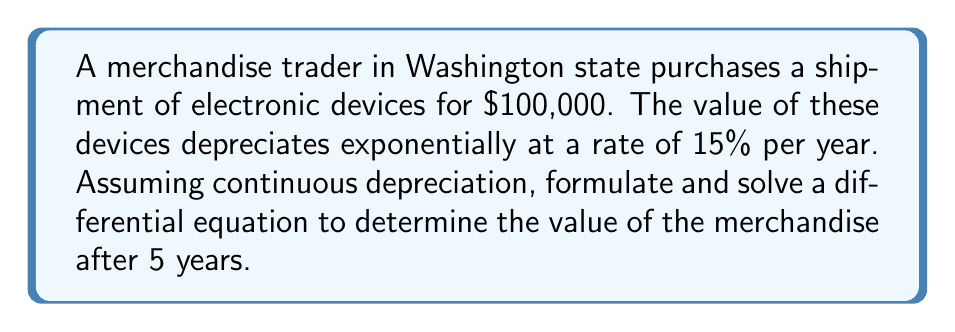Show me your answer to this math problem. Let's approach this problem step by step:

1) Let $V(t)$ be the value of the merchandise at time $t$ (in years).

2) The initial value is $V(0) = 100,000$.

3) The rate of depreciation is proportional to the current value, which gives us the differential equation:

   $$\frac{dV}{dt} = -0.15V$$

   The negative sign indicates that the value is decreasing.

4) This is a separable first-order differential equation. We can solve it as follows:

   $$\frac{dV}{V} = -0.15dt$$

5) Integrating both sides:

   $$\int \frac{dV}{V} = -0.15 \int dt$$

   $$\ln|V| = -0.15t + C$$

6) Taking the exponential of both sides:

   $$V = e^{-0.15t + C} = e^C \cdot e^{-0.15t}$$

7) Let $A = e^C$. Then our general solution is:

   $$V(t) = A \cdot e^{-0.15t}$$

8) Using the initial condition $V(0) = 100,000$:

   $$100,000 = A \cdot e^0 = A$$

9) Therefore, our particular solution is:

   $$V(t) = 100,000 \cdot e^{-0.15t}$$

10) To find the value after 5 years, we calculate $V(5)$:

    $$V(5) = 100,000 \cdot e^{-0.15 \cdot 5} = 100,000 \cdot e^{-0.75} \approx 47,236.66$$
Answer: The value of the merchandise after 5 years will be approximately $47,236.66. 